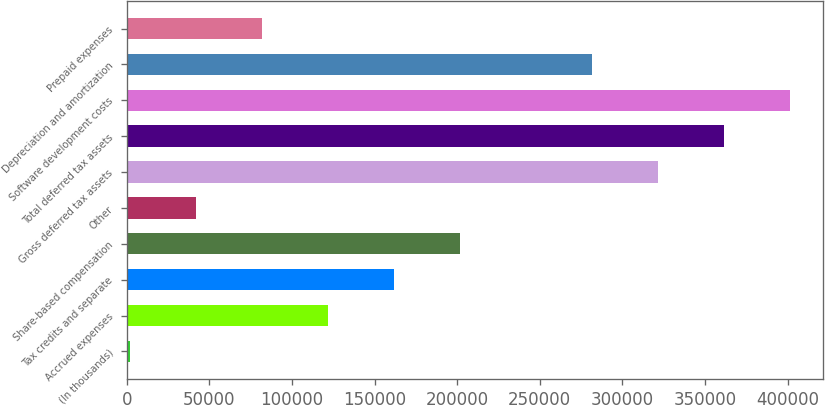Convert chart. <chart><loc_0><loc_0><loc_500><loc_500><bar_chart><fcel>(In thousands)<fcel>Accrued expenses<fcel>Tax credits and separate<fcel>Share-based compensation<fcel>Other<fcel>Gross deferred tax assets<fcel>Total deferred tax assets<fcel>Software development costs<fcel>Depreciation and amortization<fcel>Prepaid expenses<nl><fcel>2017<fcel>121905<fcel>161867<fcel>201830<fcel>41979.6<fcel>321718<fcel>361680<fcel>401643<fcel>281755<fcel>81942.2<nl></chart> 